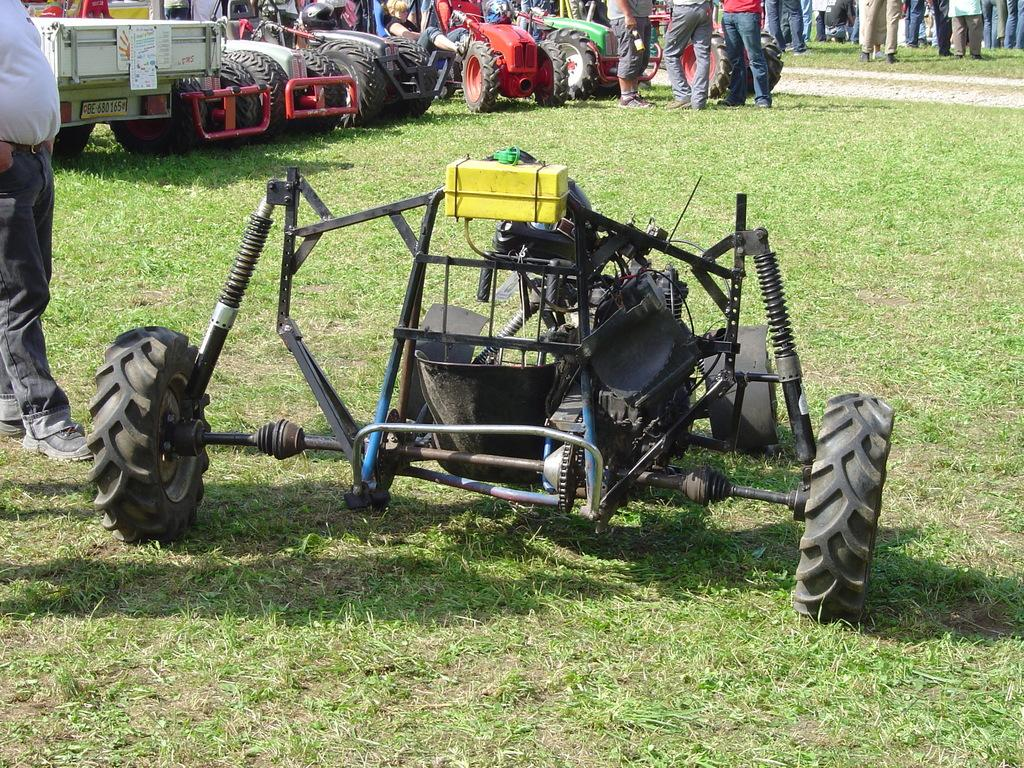What type of vehicles are on the grass in the image? The facts do not specify the type of vehicles on the grass. Can you describe the people in the image? The facts only mention that people are standing in the image, but do not provide any details about them. How many babies are crawling on the grass in the image? There are no babies present in the image. What type of crow is perched on the vehicle in the image? There is no crow present in the image. 